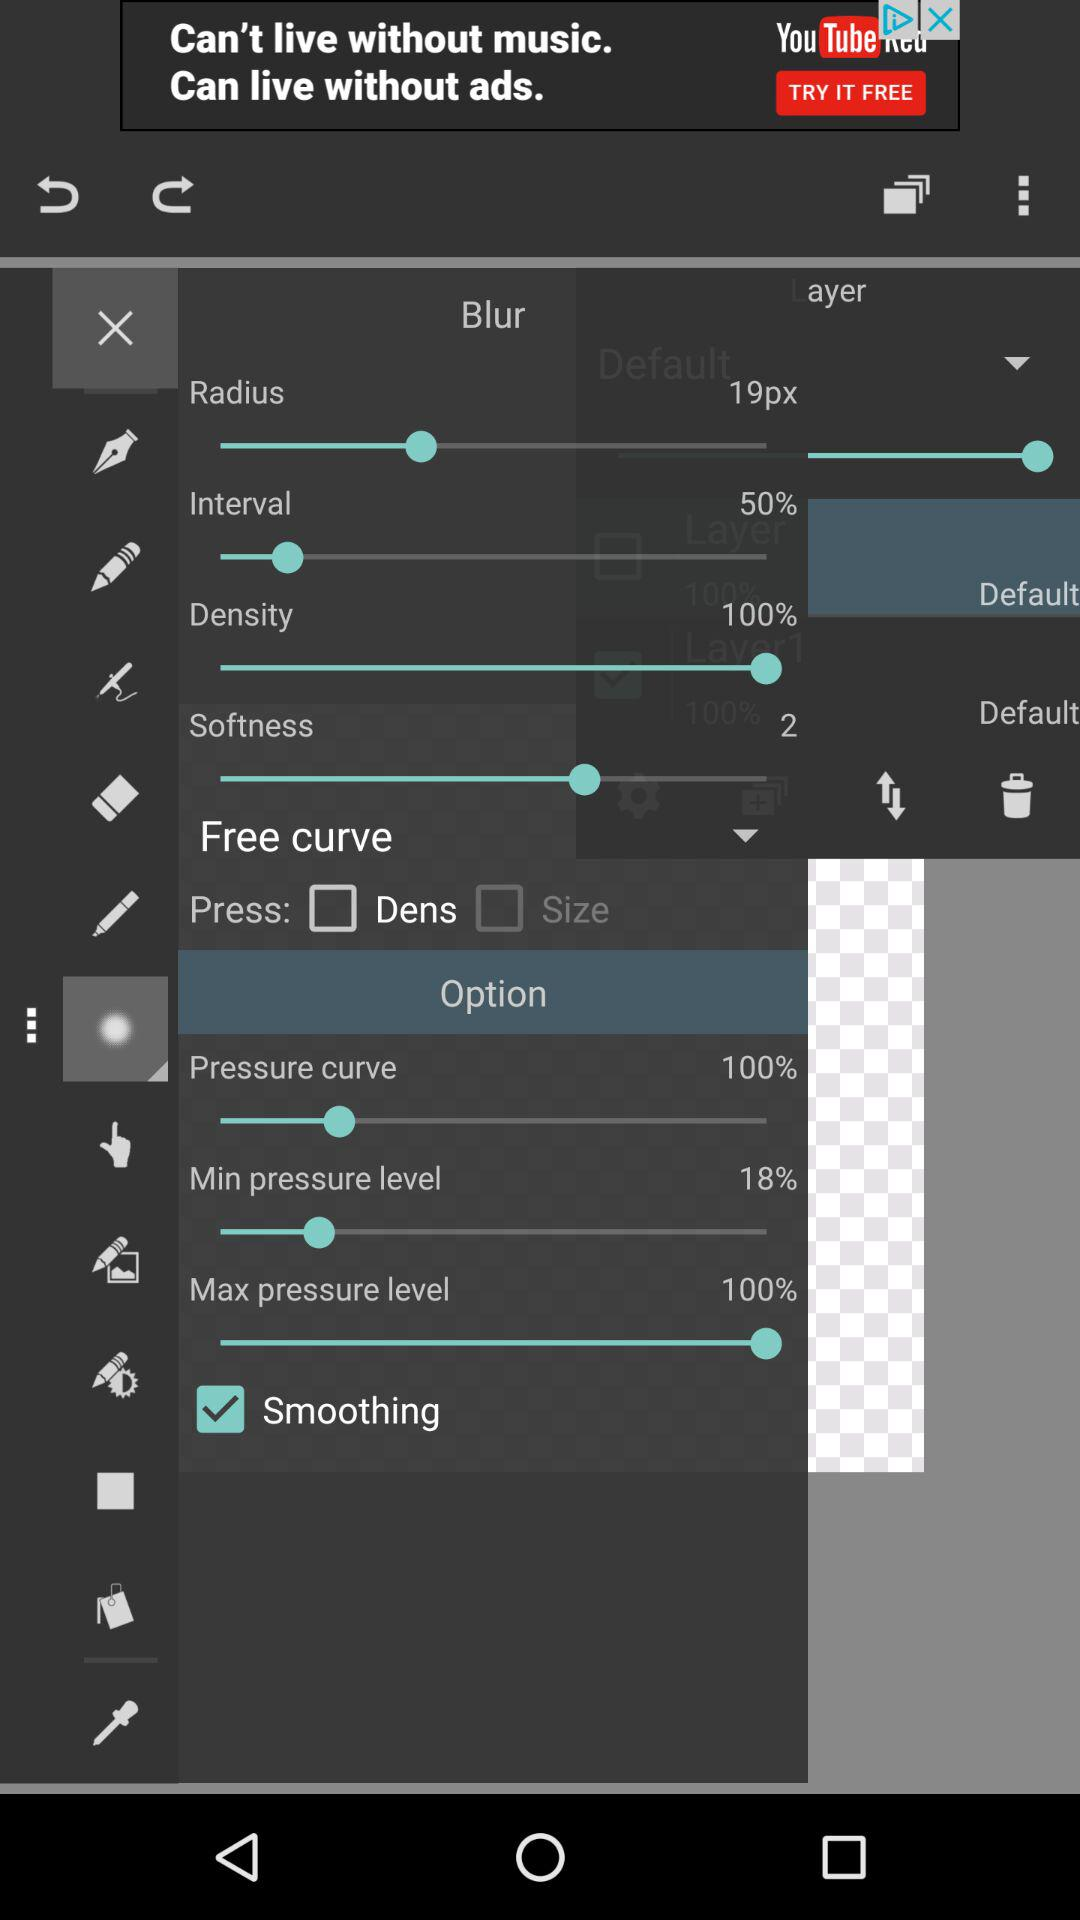What type of curve is selected?
When the provided information is insufficient, respond with <no answer>. <no answer> 